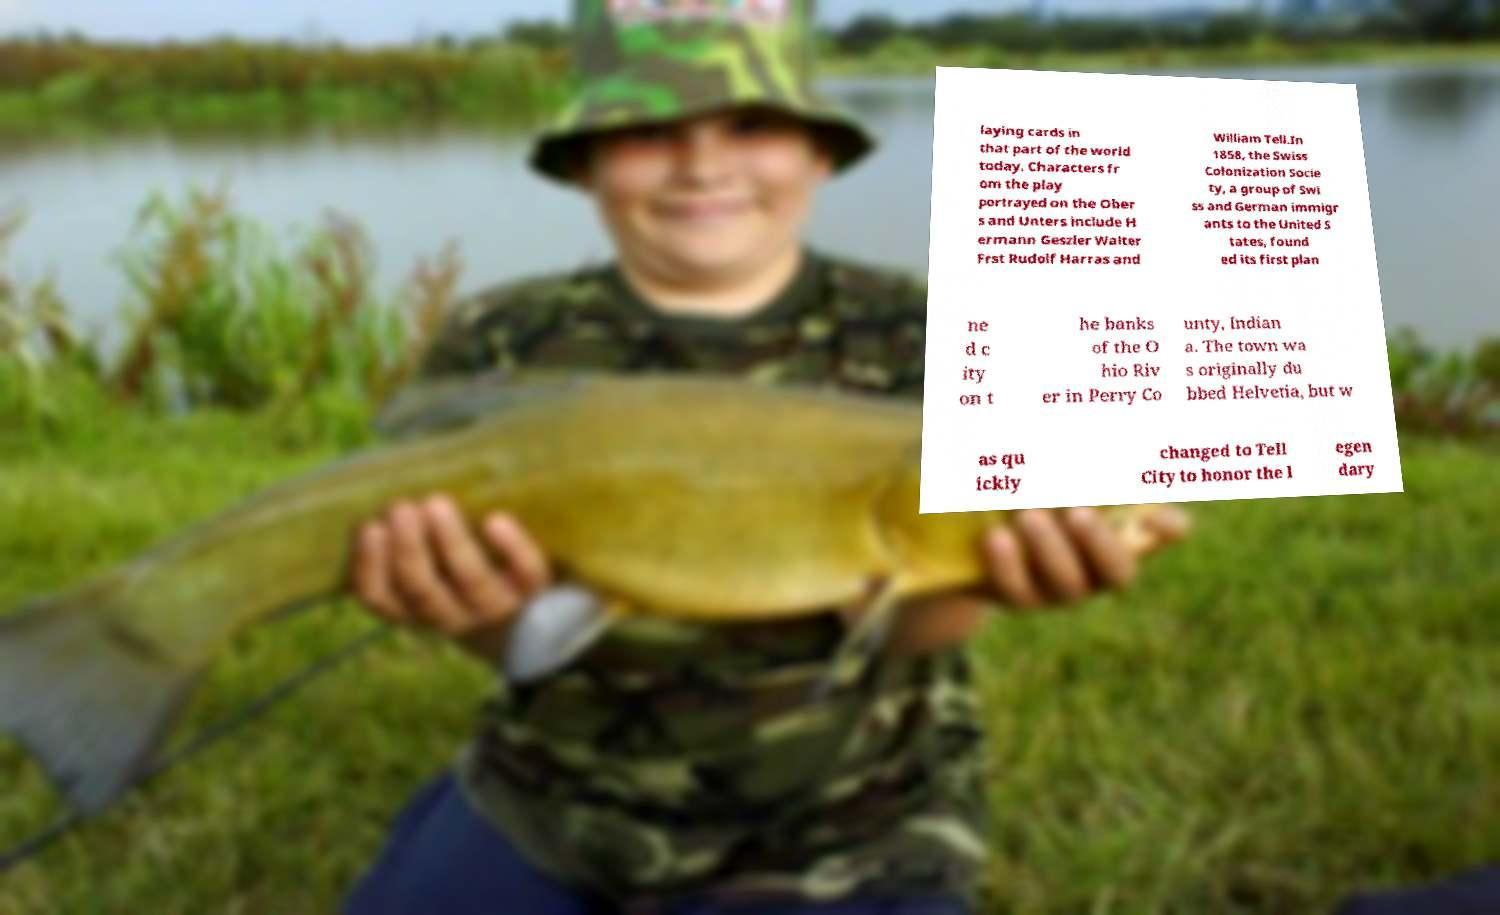Can you accurately transcribe the text from the provided image for me? laying cards in that part of the world today. Characters fr om the play portrayed on the Ober s and Unters include H ermann Geszler Walter Frst Rudolf Harras and William Tell.In 1858, the Swiss Colonization Socie ty, a group of Swi ss and German immigr ants to the United S tates, found ed its first plan ne d c ity on t he banks of the O hio Riv er in Perry Co unty, Indian a. The town wa s originally du bbed Helvetia, but w as qu ickly changed to Tell City to honor the l egen dary 